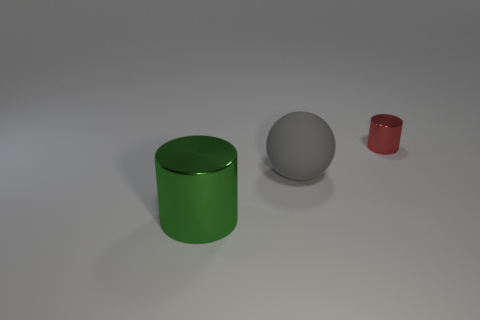Add 2 red balls. How many objects exist? 5 Subtract all balls. How many objects are left? 2 Subtract all small shiny cylinders. Subtract all small red metallic things. How many objects are left? 1 Add 2 large gray matte objects. How many large gray matte objects are left? 3 Add 2 big matte balls. How many big matte balls exist? 3 Subtract 0 brown balls. How many objects are left? 3 